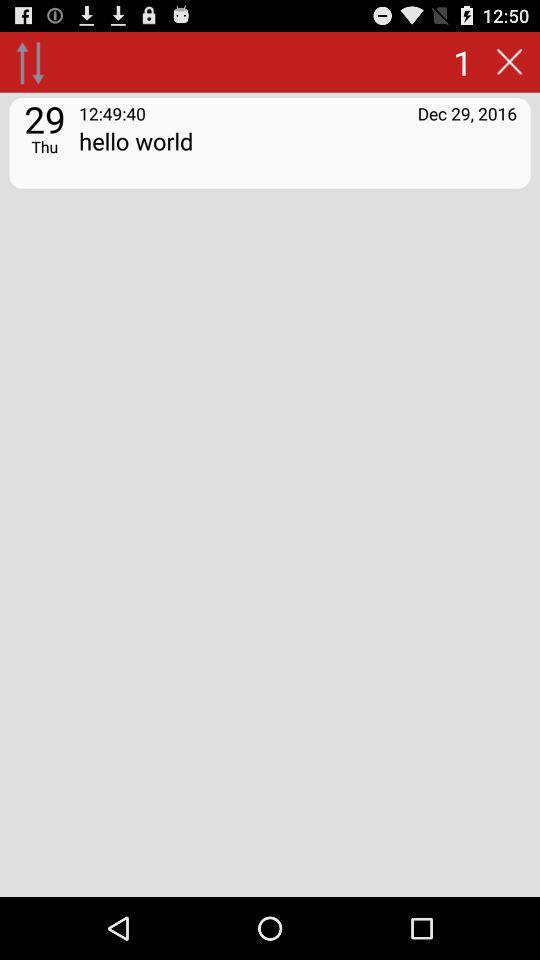At what time was the note added? The note was added at 12:49:40. 